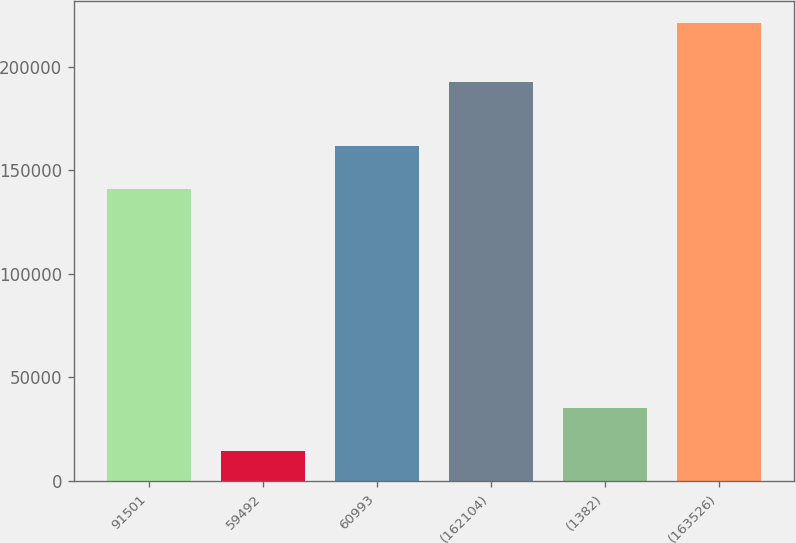Convert chart to OTSL. <chart><loc_0><loc_0><loc_500><loc_500><bar_chart><fcel>91501<fcel>59492<fcel>60993<fcel>(162104)<fcel>(1382)<fcel>(163526)<nl><fcel>140980<fcel>14590<fcel>161626<fcel>192530<fcel>35235.8<fcel>221048<nl></chart> 